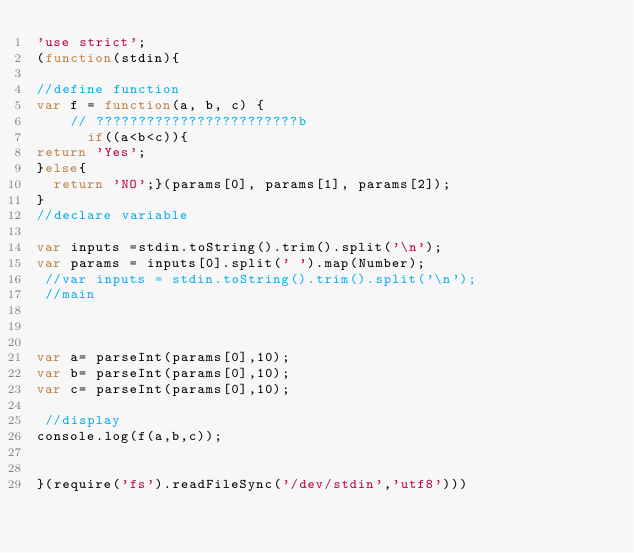Convert code to text. <code><loc_0><loc_0><loc_500><loc_500><_JavaScript_>'use strict';
(function(stdin){

//define function
var f = function(a, b, c) {
    // ????????????????????????b
      if((a<b<c)){
return 'Yes';
}else{
  return 'NO';}(params[0], params[1], params[2]);
}
//declare variable

var inputs =stdin.toString().trim().split('\n');
var params = inputs[0].split(' ').map(Number);
 //var inputs = stdin.toString().trim().split('\n');
 //main



var a= parseInt(params[0],10);
var b= parseInt(params[0],10);
var c= parseInt(params[0],10);

 //display
console.log(f(a,b,c));


}(require('fs').readFileSync('/dev/stdin','utf8')))</code> 